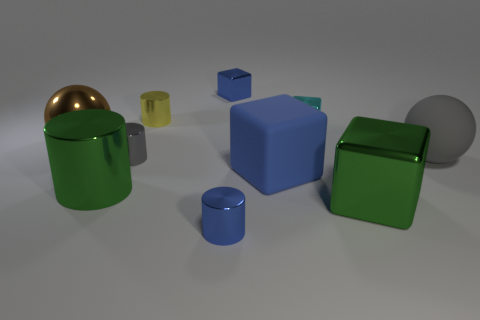What shape is the metal object that is the same color as the rubber ball?
Your response must be concise. Cylinder. Is the material of the large cylinder behind the tiny blue metallic cylinder the same as the large gray object?
Provide a succinct answer. No. There is a big sphere right of the shiny cylinder behind the small gray shiny thing; what is its material?
Your response must be concise. Rubber. What number of brown metal objects are the same shape as the gray rubber object?
Give a very brief answer. 1. There is a metallic block in front of the large ball on the left side of the metallic cylinder that is on the right side of the yellow cylinder; what is its size?
Your answer should be compact. Large. What number of cyan objects are large rubber things or tiny matte cylinders?
Offer a very short reply. 0. There is a tiny blue object that is in front of the small gray cylinder; is its shape the same as the gray matte thing?
Ensure brevity in your answer.  No. Is the number of brown spheres that are right of the gray ball greater than the number of large brown metal balls?
Offer a terse response. No. How many gray rubber spheres are the same size as the yellow object?
Make the answer very short. 0. There is a shiny cylinder that is the same color as the matte ball; what size is it?
Keep it short and to the point. Small. 